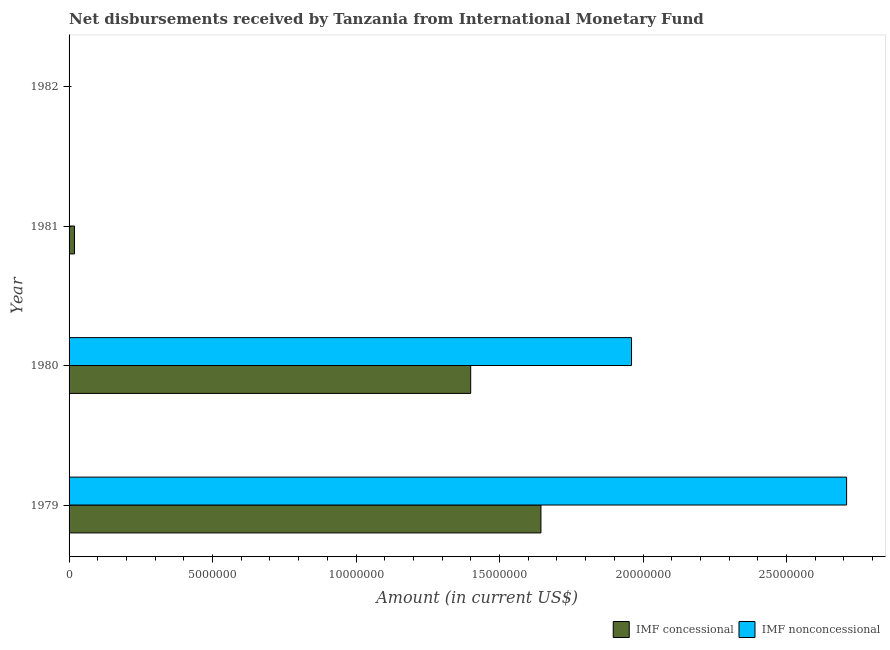How many different coloured bars are there?
Keep it short and to the point. 2. Are the number of bars per tick equal to the number of legend labels?
Keep it short and to the point. No. How many bars are there on the 2nd tick from the bottom?
Your answer should be compact. 2. What is the label of the 1st group of bars from the top?
Provide a succinct answer. 1982. In how many cases, is the number of bars for a given year not equal to the number of legend labels?
Ensure brevity in your answer.  2. What is the net non concessional disbursements from imf in 1979?
Make the answer very short. 2.71e+07. Across all years, what is the maximum net non concessional disbursements from imf?
Your answer should be very brief. 2.71e+07. Across all years, what is the minimum net concessional disbursements from imf?
Offer a terse response. 0. In which year was the net non concessional disbursements from imf maximum?
Your answer should be compact. 1979. What is the total net concessional disbursements from imf in the graph?
Provide a short and direct response. 3.06e+07. What is the difference between the net non concessional disbursements from imf in 1979 and that in 1980?
Keep it short and to the point. 7.50e+06. What is the difference between the net non concessional disbursements from imf in 1980 and the net concessional disbursements from imf in 1981?
Offer a terse response. 1.94e+07. What is the average net concessional disbursements from imf per year?
Offer a very short reply. 7.66e+06. In the year 1979, what is the difference between the net concessional disbursements from imf and net non concessional disbursements from imf?
Keep it short and to the point. -1.07e+07. What is the ratio of the net non concessional disbursements from imf in 1979 to that in 1980?
Ensure brevity in your answer.  1.38. Is the net concessional disbursements from imf in 1979 less than that in 1980?
Your response must be concise. No. What is the difference between the highest and the lowest net non concessional disbursements from imf?
Provide a short and direct response. 2.71e+07. In how many years, is the net non concessional disbursements from imf greater than the average net non concessional disbursements from imf taken over all years?
Ensure brevity in your answer.  2. How many bars are there?
Keep it short and to the point. 5. How many years are there in the graph?
Your answer should be very brief. 4. Are the values on the major ticks of X-axis written in scientific E-notation?
Your answer should be very brief. No. Does the graph contain any zero values?
Provide a succinct answer. Yes. Does the graph contain grids?
Your response must be concise. No. Where does the legend appear in the graph?
Ensure brevity in your answer.  Bottom right. How are the legend labels stacked?
Your answer should be very brief. Horizontal. What is the title of the graph?
Give a very brief answer. Net disbursements received by Tanzania from International Monetary Fund. Does "Investment" appear as one of the legend labels in the graph?
Your answer should be compact. No. What is the label or title of the Y-axis?
Provide a short and direct response. Year. What is the Amount (in current US$) of IMF concessional in 1979?
Make the answer very short. 1.64e+07. What is the Amount (in current US$) of IMF nonconcessional in 1979?
Make the answer very short. 2.71e+07. What is the Amount (in current US$) of IMF concessional in 1980?
Your answer should be compact. 1.40e+07. What is the Amount (in current US$) of IMF nonconcessional in 1980?
Provide a succinct answer. 1.96e+07. What is the Amount (in current US$) in IMF concessional in 1981?
Your answer should be very brief. 1.88e+05. Across all years, what is the maximum Amount (in current US$) of IMF concessional?
Provide a succinct answer. 1.64e+07. Across all years, what is the maximum Amount (in current US$) in IMF nonconcessional?
Your answer should be very brief. 2.71e+07. Across all years, what is the minimum Amount (in current US$) in IMF concessional?
Keep it short and to the point. 0. Across all years, what is the minimum Amount (in current US$) in IMF nonconcessional?
Make the answer very short. 0. What is the total Amount (in current US$) in IMF concessional in the graph?
Give a very brief answer. 3.06e+07. What is the total Amount (in current US$) of IMF nonconcessional in the graph?
Keep it short and to the point. 4.67e+07. What is the difference between the Amount (in current US$) in IMF concessional in 1979 and that in 1980?
Offer a terse response. 2.45e+06. What is the difference between the Amount (in current US$) in IMF nonconcessional in 1979 and that in 1980?
Keep it short and to the point. 7.50e+06. What is the difference between the Amount (in current US$) in IMF concessional in 1979 and that in 1981?
Provide a short and direct response. 1.63e+07. What is the difference between the Amount (in current US$) in IMF concessional in 1980 and that in 1981?
Offer a very short reply. 1.38e+07. What is the difference between the Amount (in current US$) in IMF concessional in 1979 and the Amount (in current US$) in IMF nonconcessional in 1980?
Make the answer very short. -3.16e+06. What is the average Amount (in current US$) of IMF concessional per year?
Ensure brevity in your answer.  7.66e+06. What is the average Amount (in current US$) in IMF nonconcessional per year?
Ensure brevity in your answer.  1.17e+07. In the year 1979, what is the difference between the Amount (in current US$) of IMF concessional and Amount (in current US$) of IMF nonconcessional?
Give a very brief answer. -1.07e+07. In the year 1980, what is the difference between the Amount (in current US$) in IMF concessional and Amount (in current US$) in IMF nonconcessional?
Offer a very short reply. -5.60e+06. What is the ratio of the Amount (in current US$) in IMF concessional in 1979 to that in 1980?
Your response must be concise. 1.17. What is the ratio of the Amount (in current US$) in IMF nonconcessional in 1979 to that in 1980?
Your answer should be compact. 1.38. What is the ratio of the Amount (in current US$) in IMF concessional in 1979 to that in 1981?
Ensure brevity in your answer.  87.46. What is the ratio of the Amount (in current US$) of IMF concessional in 1980 to that in 1981?
Your answer should be compact. 74.44. What is the difference between the highest and the second highest Amount (in current US$) in IMF concessional?
Give a very brief answer. 2.45e+06. What is the difference between the highest and the lowest Amount (in current US$) of IMF concessional?
Make the answer very short. 1.64e+07. What is the difference between the highest and the lowest Amount (in current US$) of IMF nonconcessional?
Ensure brevity in your answer.  2.71e+07. 